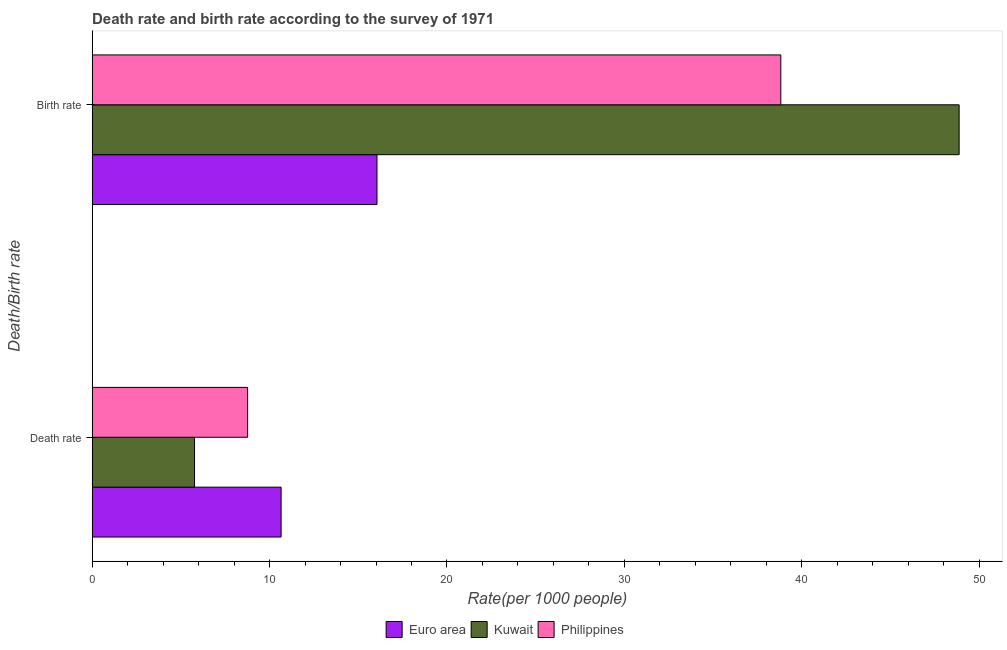Are the number of bars per tick equal to the number of legend labels?
Your response must be concise. Yes. Are the number of bars on each tick of the Y-axis equal?
Your answer should be very brief. Yes. How many bars are there on the 2nd tick from the bottom?
Give a very brief answer. 3. What is the label of the 2nd group of bars from the top?
Ensure brevity in your answer.  Death rate. What is the birth rate in Kuwait?
Ensure brevity in your answer.  48.86. Across all countries, what is the maximum birth rate?
Offer a terse response. 48.86. Across all countries, what is the minimum birth rate?
Offer a terse response. 16.05. In which country was the birth rate maximum?
Keep it short and to the point. Kuwait. In which country was the death rate minimum?
Provide a short and direct response. Kuwait. What is the total death rate in the graph?
Keep it short and to the point. 25.19. What is the difference between the birth rate in Euro area and that in Philippines?
Your answer should be very brief. -22.76. What is the difference between the death rate in Kuwait and the birth rate in Euro area?
Ensure brevity in your answer.  -10.28. What is the average death rate per country?
Your answer should be compact. 8.4. What is the difference between the birth rate and death rate in Euro area?
Keep it short and to the point. 5.4. What is the ratio of the birth rate in Philippines to that in Euro area?
Provide a short and direct response. 2.42. Is the birth rate in Kuwait less than that in Philippines?
Keep it short and to the point. No. In how many countries, is the birth rate greater than the average birth rate taken over all countries?
Offer a terse response. 2. What does the 3rd bar from the bottom in Birth rate represents?
Provide a succinct answer. Philippines. Are all the bars in the graph horizontal?
Your answer should be compact. Yes. What is the difference between two consecutive major ticks on the X-axis?
Your response must be concise. 10. Are the values on the major ticks of X-axis written in scientific E-notation?
Keep it short and to the point. No. Where does the legend appear in the graph?
Your response must be concise. Bottom center. What is the title of the graph?
Your response must be concise. Death rate and birth rate according to the survey of 1971. What is the label or title of the X-axis?
Give a very brief answer. Rate(per 1000 people). What is the label or title of the Y-axis?
Offer a terse response. Death/Birth rate. What is the Rate(per 1000 people) of Euro area in Death rate?
Offer a terse response. 10.65. What is the Rate(per 1000 people) in Kuwait in Death rate?
Your answer should be very brief. 5.77. What is the Rate(per 1000 people) in Philippines in Death rate?
Keep it short and to the point. 8.76. What is the Rate(per 1000 people) of Euro area in Birth rate?
Your answer should be very brief. 16.05. What is the Rate(per 1000 people) in Kuwait in Birth rate?
Your answer should be compact. 48.86. What is the Rate(per 1000 people) in Philippines in Birth rate?
Give a very brief answer. 38.81. Across all Death/Birth rate, what is the maximum Rate(per 1000 people) of Euro area?
Give a very brief answer. 16.05. Across all Death/Birth rate, what is the maximum Rate(per 1000 people) in Kuwait?
Offer a terse response. 48.86. Across all Death/Birth rate, what is the maximum Rate(per 1000 people) of Philippines?
Offer a terse response. 38.81. Across all Death/Birth rate, what is the minimum Rate(per 1000 people) in Euro area?
Your answer should be very brief. 10.65. Across all Death/Birth rate, what is the minimum Rate(per 1000 people) in Kuwait?
Your answer should be compact. 5.77. Across all Death/Birth rate, what is the minimum Rate(per 1000 people) of Philippines?
Provide a short and direct response. 8.76. What is the total Rate(per 1000 people) of Euro area in the graph?
Offer a terse response. 26.71. What is the total Rate(per 1000 people) in Kuwait in the graph?
Your answer should be very brief. 54.63. What is the total Rate(per 1000 people) in Philippines in the graph?
Provide a short and direct response. 47.58. What is the difference between the Rate(per 1000 people) in Euro area in Death rate and that in Birth rate?
Offer a very short reply. -5.4. What is the difference between the Rate(per 1000 people) in Kuwait in Death rate and that in Birth rate?
Your answer should be very brief. -43.09. What is the difference between the Rate(per 1000 people) in Philippines in Death rate and that in Birth rate?
Give a very brief answer. -30.05. What is the difference between the Rate(per 1000 people) in Euro area in Death rate and the Rate(per 1000 people) in Kuwait in Birth rate?
Give a very brief answer. -38.21. What is the difference between the Rate(per 1000 people) in Euro area in Death rate and the Rate(per 1000 people) in Philippines in Birth rate?
Ensure brevity in your answer.  -28.16. What is the difference between the Rate(per 1000 people) of Kuwait in Death rate and the Rate(per 1000 people) of Philippines in Birth rate?
Ensure brevity in your answer.  -33.04. What is the average Rate(per 1000 people) in Euro area per Death/Birth rate?
Keep it short and to the point. 13.35. What is the average Rate(per 1000 people) of Kuwait per Death/Birth rate?
Ensure brevity in your answer.  27.32. What is the average Rate(per 1000 people) in Philippines per Death/Birth rate?
Your answer should be compact. 23.79. What is the difference between the Rate(per 1000 people) in Euro area and Rate(per 1000 people) in Kuwait in Death rate?
Make the answer very short. 4.88. What is the difference between the Rate(per 1000 people) of Euro area and Rate(per 1000 people) of Philippines in Death rate?
Provide a short and direct response. 1.89. What is the difference between the Rate(per 1000 people) in Kuwait and Rate(per 1000 people) in Philippines in Death rate?
Provide a succinct answer. -2.99. What is the difference between the Rate(per 1000 people) in Euro area and Rate(per 1000 people) in Kuwait in Birth rate?
Make the answer very short. -32.81. What is the difference between the Rate(per 1000 people) of Euro area and Rate(per 1000 people) of Philippines in Birth rate?
Offer a very short reply. -22.76. What is the difference between the Rate(per 1000 people) in Kuwait and Rate(per 1000 people) in Philippines in Birth rate?
Your response must be concise. 10.05. What is the ratio of the Rate(per 1000 people) in Euro area in Death rate to that in Birth rate?
Give a very brief answer. 0.66. What is the ratio of the Rate(per 1000 people) in Kuwait in Death rate to that in Birth rate?
Offer a terse response. 0.12. What is the ratio of the Rate(per 1000 people) of Philippines in Death rate to that in Birth rate?
Provide a succinct answer. 0.23. What is the difference between the highest and the second highest Rate(per 1000 people) of Euro area?
Offer a terse response. 5.4. What is the difference between the highest and the second highest Rate(per 1000 people) in Kuwait?
Make the answer very short. 43.09. What is the difference between the highest and the second highest Rate(per 1000 people) in Philippines?
Your answer should be compact. 30.05. What is the difference between the highest and the lowest Rate(per 1000 people) of Euro area?
Your response must be concise. 5.4. What is the difference between the highest and the lowest Rate(per 1000 people) in Kuwait?
Ensure brevity in your answer.  43.09. What is the difference between the highest and the lowest Rate(per 1000 people) of Philippines?
Provide a short and direct response. 30.05. 